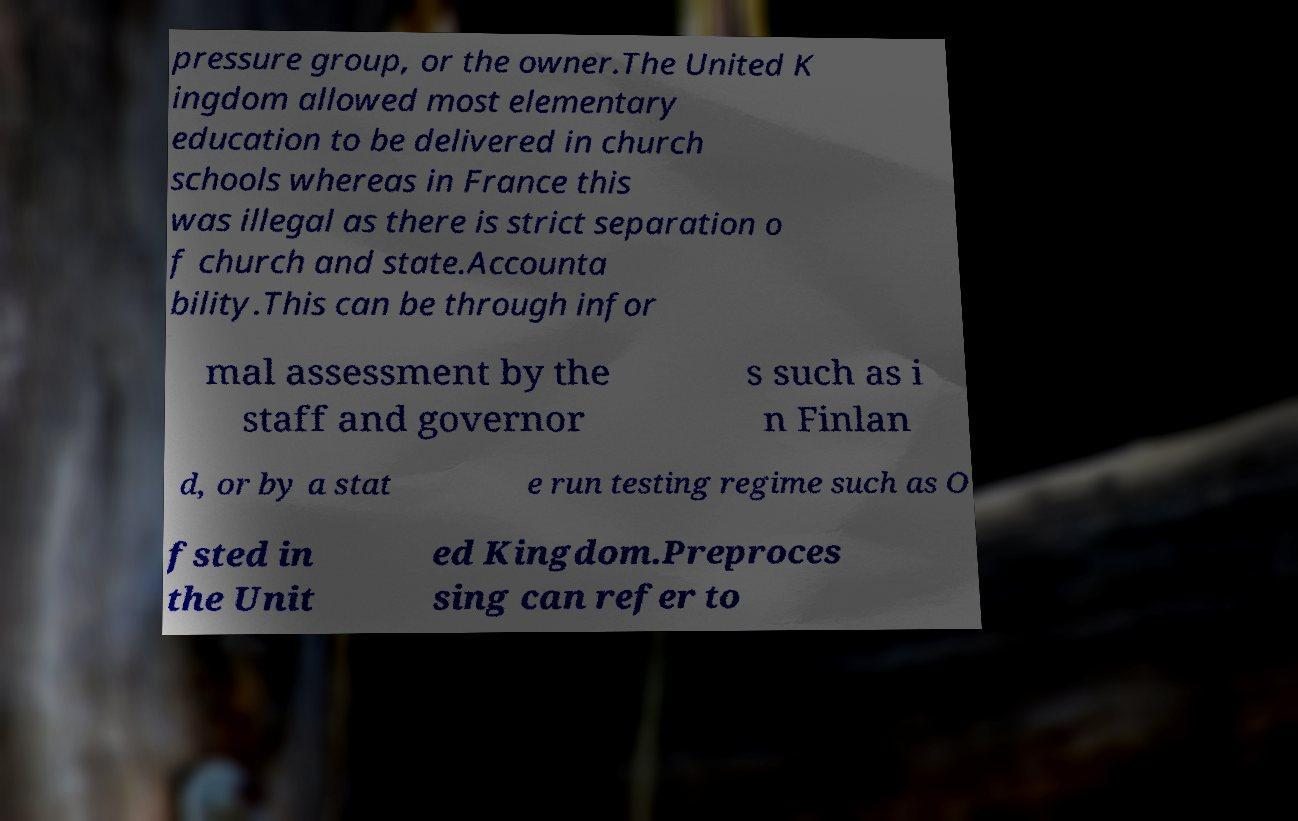What messages or text are displayed in this image? I need them in a readable, typed format. pressure group, or the owner.The United K ingdom allowed most elementary education to be delivered in church schools whereas in France this was illegal as there is strict separation o f church and state.Accounta bility.This can be through infor mal assessment by the staff and governor s such as i n Finlan d, or by a stat e run testing regime such as O fsted in the Unit ed Kingdom.Preproces sing can refer to 